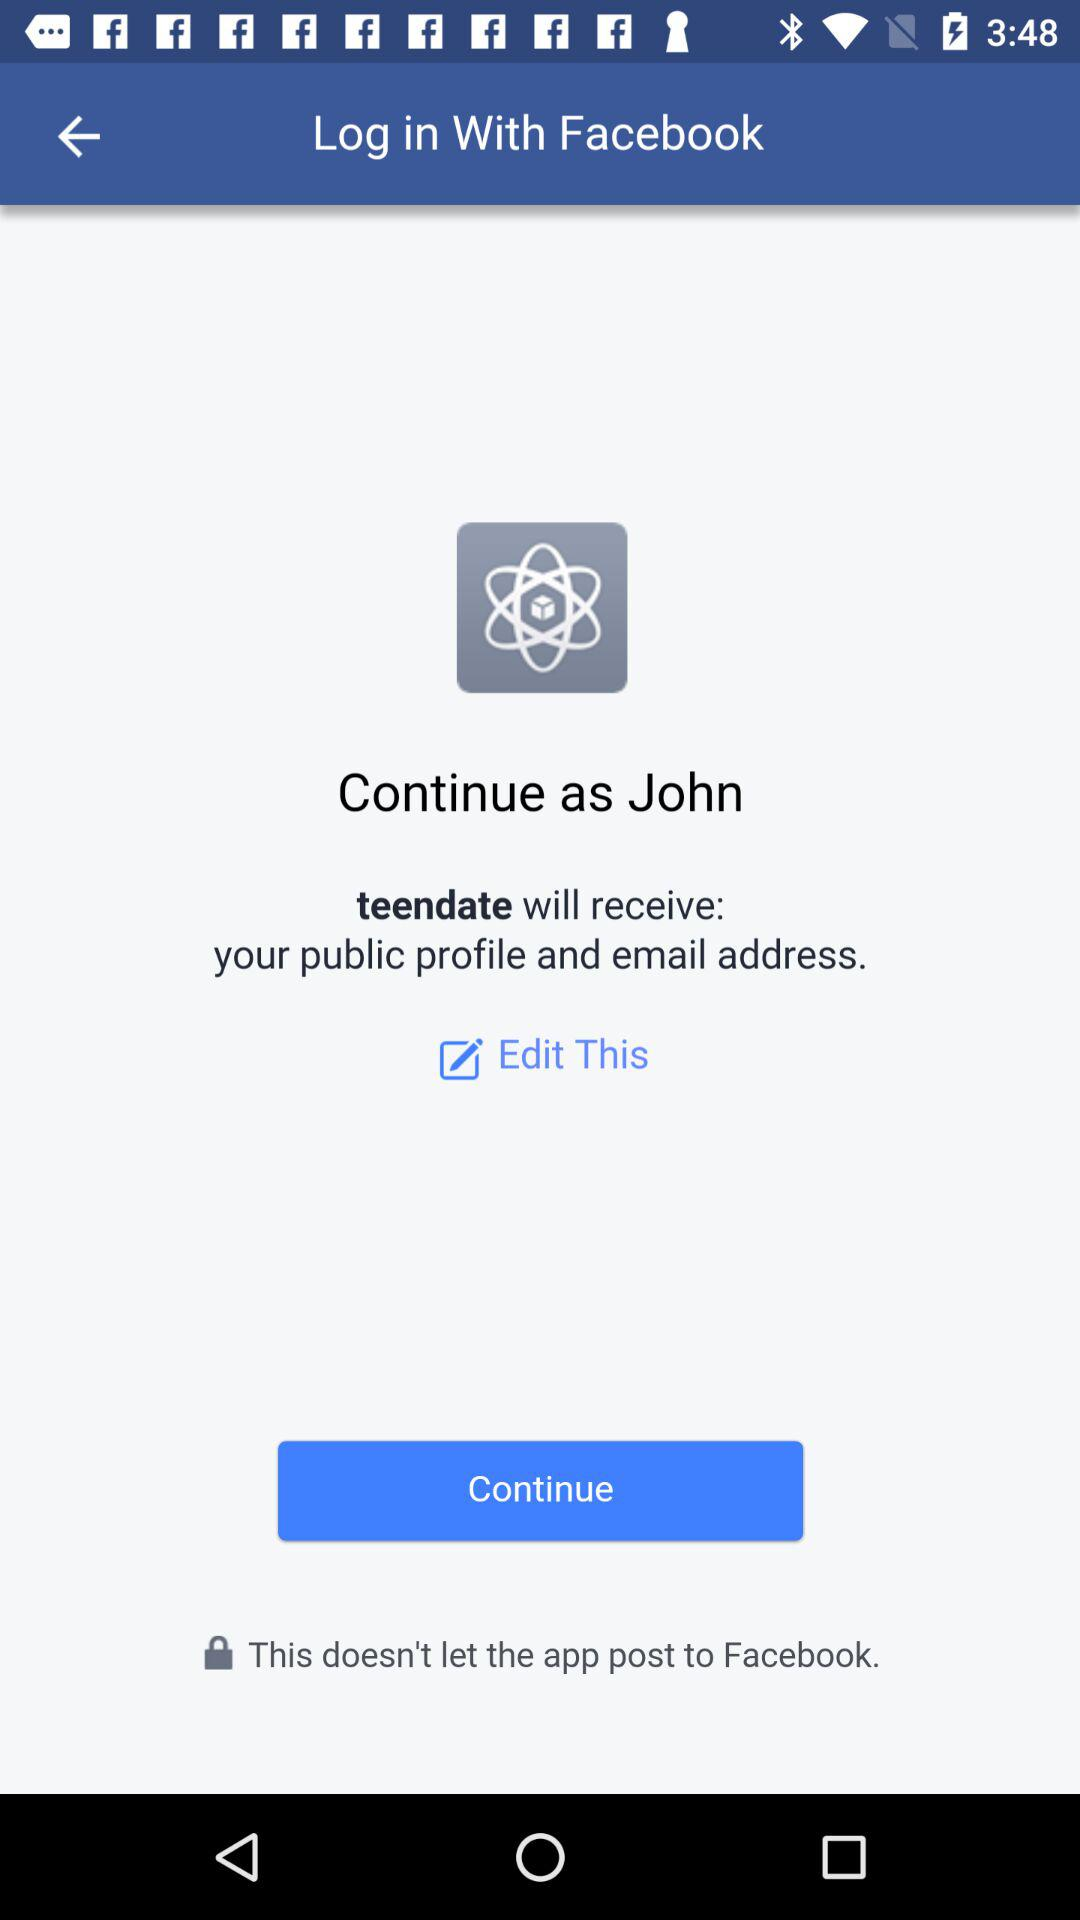Who will receive the public profile and email address? The application "teendate" will receive the public profile and email address. 